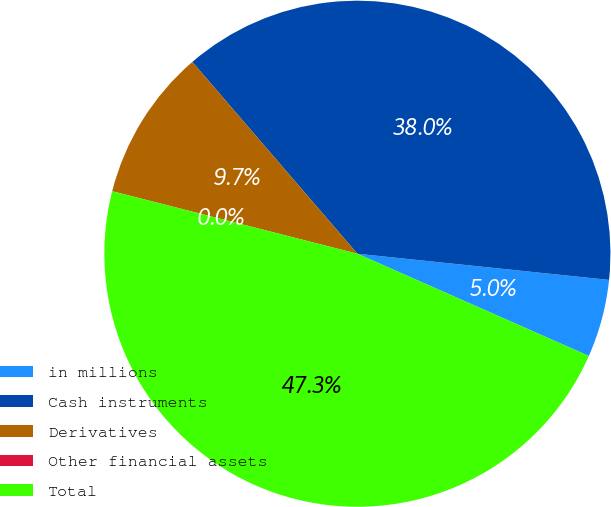Convert chart. <chart><loc_0><loc_0><loc_500><loc_500><pie_chart><fcel>in millions<fcel>Cash instruments<fcel>Derivatives<fcel>Other financial assets<fcel>Total<nl><fcel>4.97%<fcel>37.96%<fcel>9.71%<fcel>0.01%<fcel>47.35%<nl></chart> 